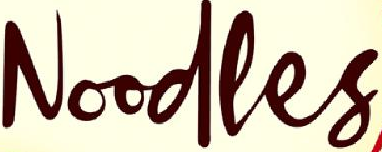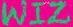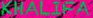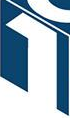What words can you see in these images in sequence, separated by a semicolon? Noodles; WIZ; KHALIFA; 1 